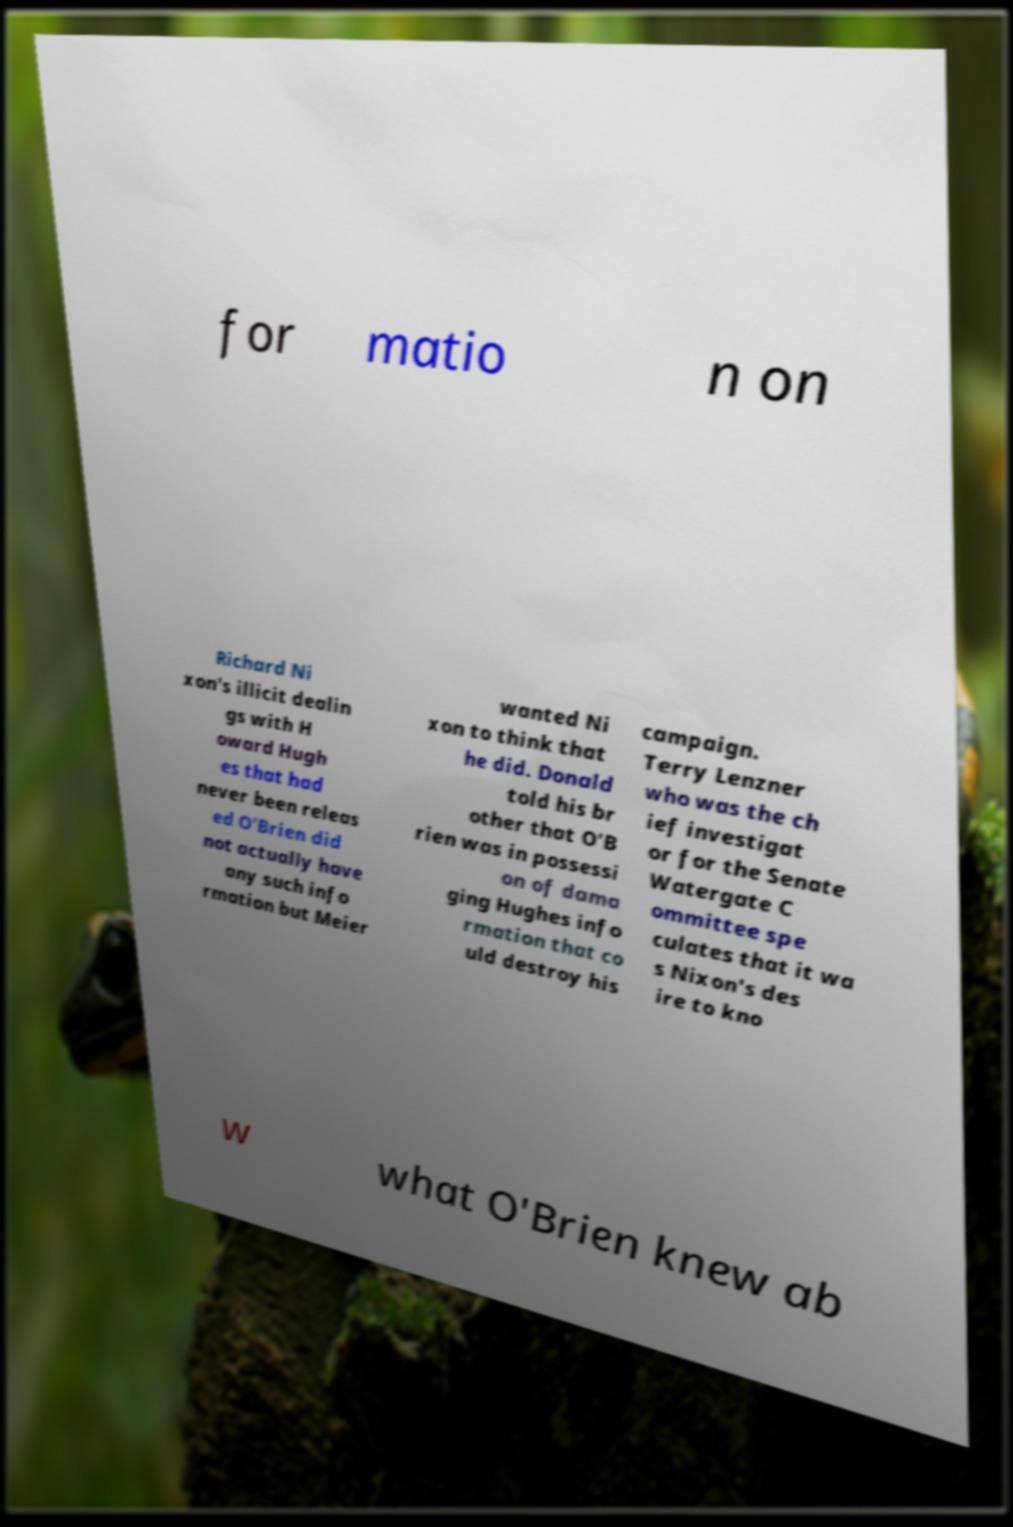What messages or text are displayed in this image? I need them in a readable, typed format. for matio n on Richard Ni xon's illicit dealin gs with H oward Hugh es that had never been releas ed O'Brien did not actually have any such info rmation but Meier wanted Ni xon to think that he did. Donald told his br other that O'B rien was in possessi on of dama ging Hughes info rmation that co uld destroy his campaign. Terry Lenzner who was the ch ief investigat or for the Senate Watergate C ommittee spe culates that it wa s Nixon's des ire to kno w what O'Brien knew ab 